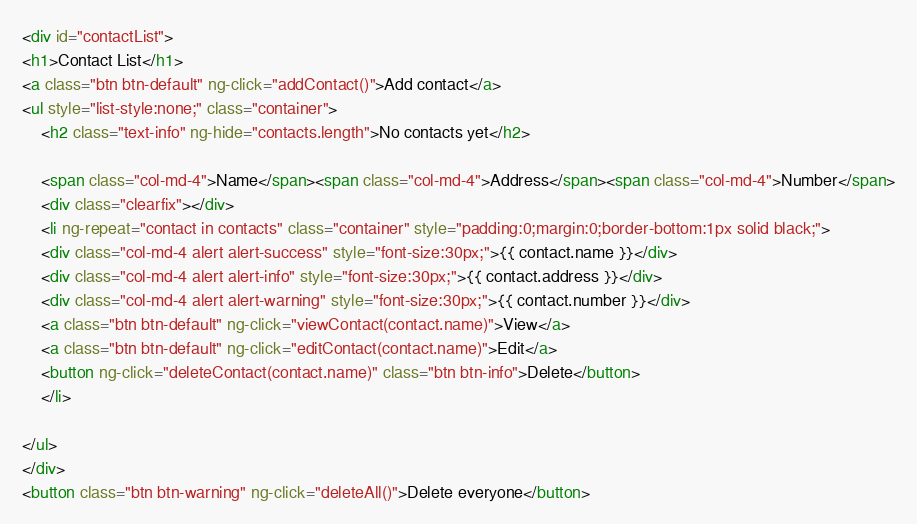Convert code to text. <code><loc_0><loc_0><loc_500><loc_500><_HTML_><div id="contactList">
<h1>Contact List</h1>
<a class="btn btn-default" ng-click="addContact()">Add contact</a>
<ul style="list-style:none;" class="container">
    <h2 class="text-info" ng-hide="contacts.length">No contacts yet</h2>
    
    <span class="col-md-4">Name</span><span class="col-md-4">Address</span><span class="col-md-4">Number</span>
    <div class="clearfix"></div>
    <li ng-repeat="contact in contacts" class="container" style="padding:0;margin:0;border-bottom:1px solid black;">
    <div class="col-md-4 alert alert-success" style="font-size:30px;">{{ contact.name }}</div>
    <div class="col-md-4 alert alert-info" style="font-size:30px;">{{ contact.address }}</div>
    <div class="col-md-4 alert alert-warning" style="font-size:30px;">{{ contact.number }}</div>
    <a class="btn btn-default" ng-click="viewContact(contact.name)">View</a>
    <a class="btn btn-default" ng-click="editContact(contact.name)">Edit</a>
    <button ng-click="deleteContact(contact.name)" class="btn btn-info">Delete</button>
    </li>
    
</ul>
</div>
<button class="btn btn-warning" ng-click="deleteAll()">Delete everyone</button>
</code> 